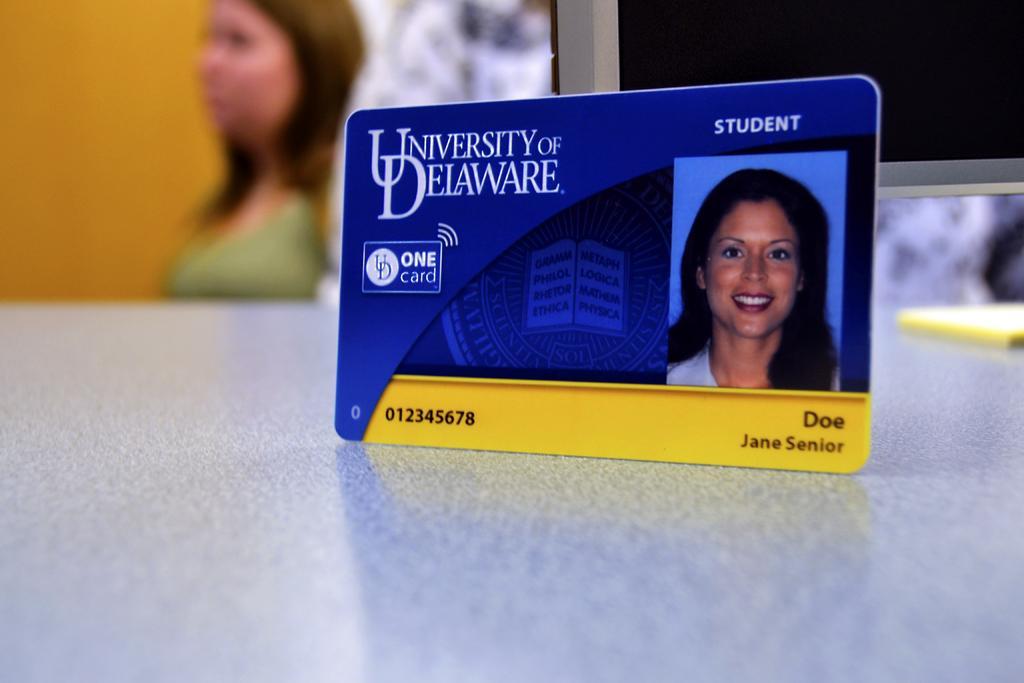Could you give a brief overview of what you see in this image? In this image we can see an id card placed on the table. On the right there is an object. In the background there is a person and a wall. 